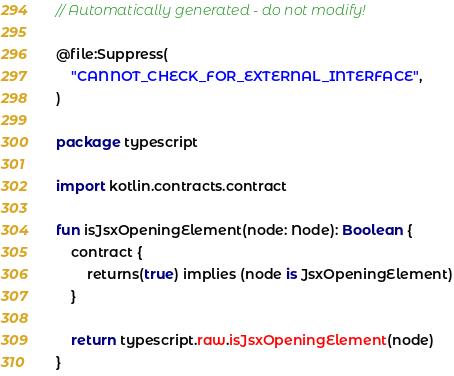<code> <loc_0><loc_0><loc_500><loc_500><_Kotlin_>// Automatically generated - do not modify!

@file:Suppress(
    "CANNOT_CHECK_FOR_EXTERNAL_INTERFACE",
)

package typescript

import kotlin.contracts.contract

fun isJsxOpeningElement(node: Node): Boolean {
    contract {
        returns(true) implies (node is JsxOpeningElement)
    }

    return typescript.raw.isJsxOpeningElement(node)
}
</code> 